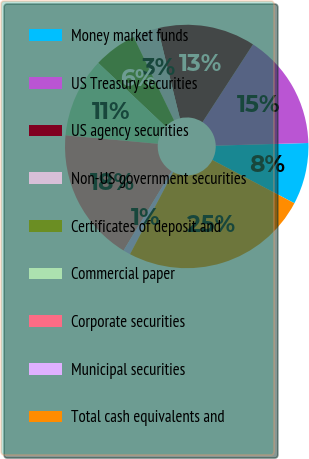Convert chart to OTSL. <chart><loc_0><loc_0><loc_500><loc_500><pie_chart><fcel>Money market funds<fcel>US Treasury securities<fcel>US agency securities<fcel>Non-US government securities<fcel>Certificates of deposit and<fcel>Commercial paper<fcel>Corporate securities<fcel>Municipal securities<fcel>Total cash equivalents and<nl><fcel>8.18%<fcel>15.38%<fcel>12.98%<fcel>3.37%<fcel>5.77%<fcel>10.58%<fcel>17.78%<fcel>0.97%<fcel>24.99%<nl></chart> 